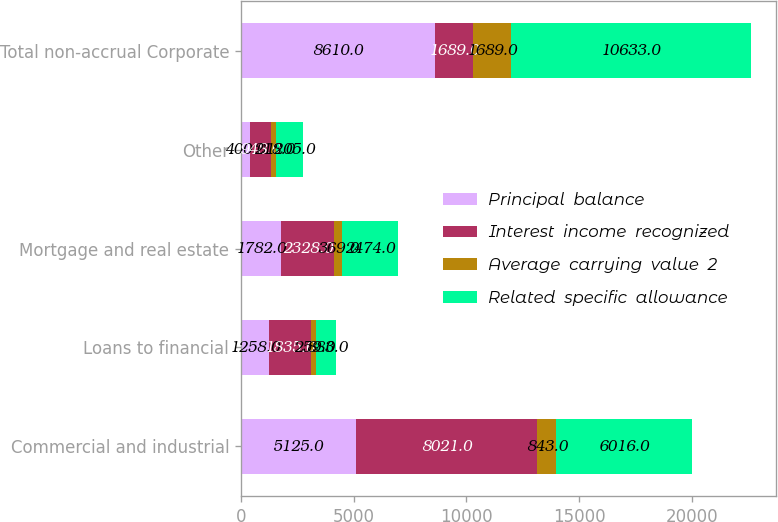Convert chart to OTSL. <chart><loc_0><loc_0><loc_500><loc_500><stacked_bar_chart><ecel><fcel>Commercial and industrial<fcel>Loans to financial<fcel>Mortgage and real estate<fcel>Other<fcel>Total non-accrual Corporate<nl><fcel>Principal  balance<fcel>5125<fcel>1258<fcel>1782<fcel>400<fcel>8610<nl><fcel>Interest  income  recognized<fcel>8021<fcel>1835<fcel>2328<fcel>948<fcel>1689<nl><fcel>Average  carrying  value  2<fcel>843<fcel>259<fcel>369<fcel>218<fcel>1689<nl><fcel>Related  specific  allowance<fcel>6016<fcel>883<fcel>2474<fcel>1205<fcel>10633<nl></chart> 